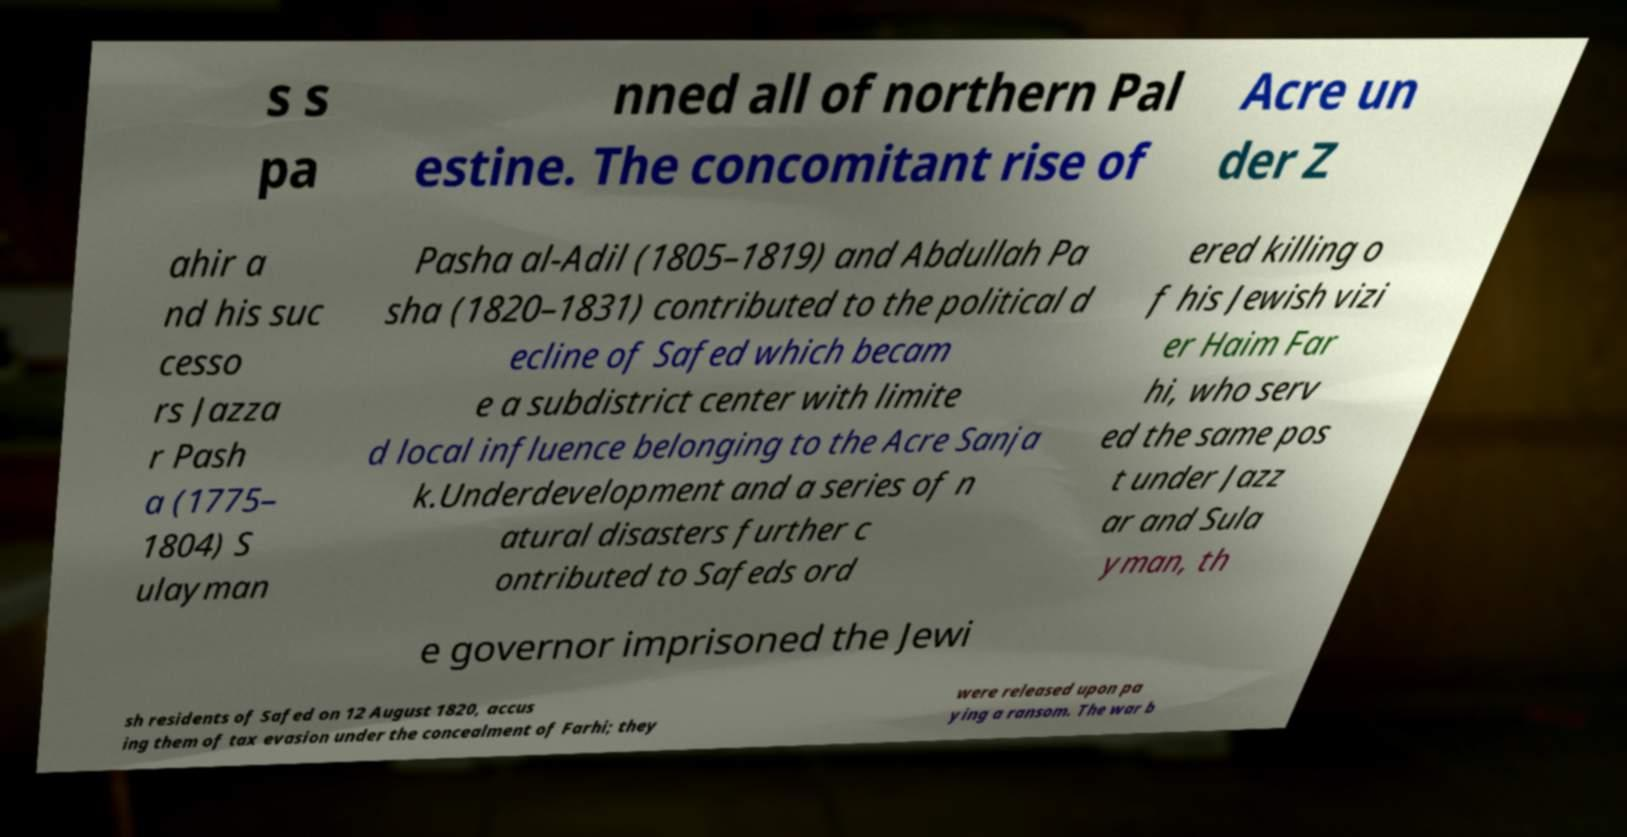For documentation purposes, I need the text within this image transcribed. Could you provide that? s s pa nned all of northern Pal estine. The concomitant rise of Acre un der Z ahir a nd his suc cesso rs Jazza r Pash a (1775– 1804) S ulayman Pasha al-Adil (1805–1819) and Abdullah Pa sha (1820–1831) contributed to the political d ecline of Safed which becam e a subdistrict center with limite d local influence belonging to the Acre Sanja k.Underdevelopment and a series of n atural disasters further c ontributed to Safeds ord ered killing o f his Jewish vizi er Haim Far hi, who serv ed the same pos t under Jazz ar and Sula yman, th e governor imprisoned the Jewi sh residents of Safed on 12 August 1820, accus ing them of tax evasion under the concealment of Farhi; they were released upon pa ying a ransom. The war b 